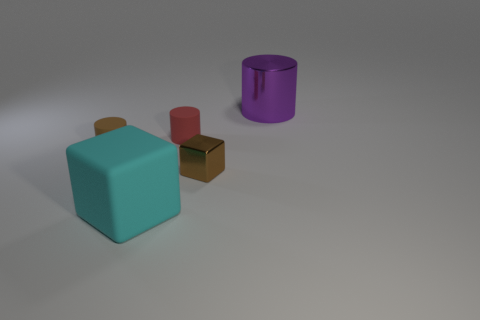Are there fewer big metal things that are left of the tiny brown matte cylinder than large brown shiny things?
Your answer should be very brief. No. Is the large cyan block made of the same material as the cylinder right of the metallic cube?
Ensure brevity in your answer.  No. What is the big cylinder made of?
Make the answer very short. Metal. What is the material of the brown object in front of the small brown rubber object that is behind the metallic object in front of the metallic cylinder?
Your answer should be compact. Metal. Do the metallic cube and the small matte cylinder that is on the left side of the large cyan matte thing have the same color?
Provide a short and direct response. Yes. What is the color of the small rubber thing to the left of the block in front of the brown metal thing?
Keep it short and to the point. Brown. What number of large purple objects are there?
Your answer should be very brief. 1. What number of matte objects are either big yellow cylinders or large cubes?
Offer a terse response. 1. What number of small matte cylinders are the same color as the tiny metal block?
Keep it short and to the point. 1. What is the material of the thing that is in front of the cube that is to the right of the red matte cylinder?
Ensure brevity in your answer.  Rubber. 